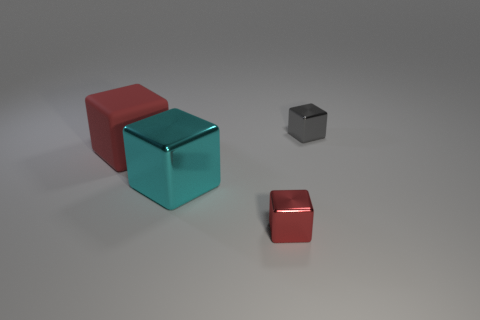Considering the lighting in the scene, what time of day or setting does it seem to represent? The lighting in the scene suggests an artificial, indoor setting. There doesn't appear to be natural light, as one might expect from sunlight or a specific time of day, but rather controlled, ambient lighting that is evenly distributed across the scene. 